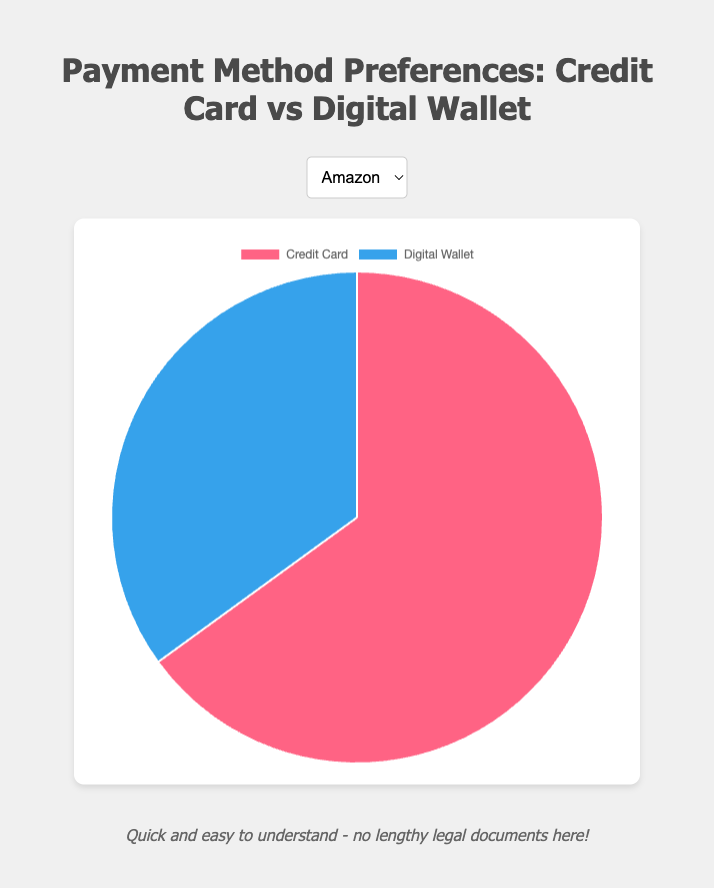What percentage of Amazon shoppers prefer using a Credit Card? The pie chart for Amazon shows that the 'Credit Card' segment represents a larger share, with the percentage explicitly indicated as 65%.
Answer: 65% Is the proportion of Digital Wallet users higher on Alibaba or Etsy? By comparing the pie charts, we can see that the Digital Wallet segment for Alibaba is 60% while for Etsy it's 45%. Therefore, Alibaba has a higher proportion of Digital Wallet users.
Answer: Alibaba Which entity has an equal preference between Credit Card and Digital Wallet? Looking at the pie charts, eBay is the only entity that shows an equal split between 'Credit Card' and 'Digital Wallet', each at 50%.
Answer: eBay For Walmart, how much more preferred is the Credit Card over the Digital Wallet? The pie chart for Walmart displays a 70% preference for Credit Card and a 30% for Digital Wallet. The difference is calculated as 70% - 30% = 40%.
Answer: 40% Which payment method is more preferred at Etsy, and by how much? The pie chart for Etsy shows 55% preference for Credit Card and 45% for Digital Wallet. Therefore, Credit Card is more preferred by a margin of 55% - 45% = 10%.
Answer: Credit Card, by 10% Calculate the average preference for Digital Wallet across all entities. The Digital Wallet preferences are 35% for Amazon, 50% for eBay, 30% for Walmart, 45% for Etsy, and 60% for Alibaba. Adding these gives 35 + 50 + 30 + 45 + 60 = 220. Dividing by 5 entities gives an average of 220 / 5 = 44%.
Answer: 44% Based on the pie charts, which entity has the highest preference for Digital Wallet? By examining each pie chart, Alibaba shows the highest preference for Digital Wallet at 60%, higher than any other entity.
Answer: Alibaba How does the preference for Credit Card at Amazon compare to that at Alibaba? The pie chart indicates that Amazon has a 65% preference for Credit Card and Alibaba has a 40% preference. Amazon's preference is significantly higher by 65% - 40% = 25%.
Answer: Amazon is higher by 25% If you sum the percentage preferences for Credit Card across Amazon and Walmart, what do you get? The Credit Card preference percentages are 65% for Amazon and 70% for Walmart. Summing these yields 65 + 70 = 135%.
Answer: 135% Looking at all entities, which payment method seems to be generally more preferred? By visually scanning across all pie charts, most entities lean more towards Credit Card except Alibaba. Therefore, Credit Card appears to be generally more preferred.
Answer: Credit Card 